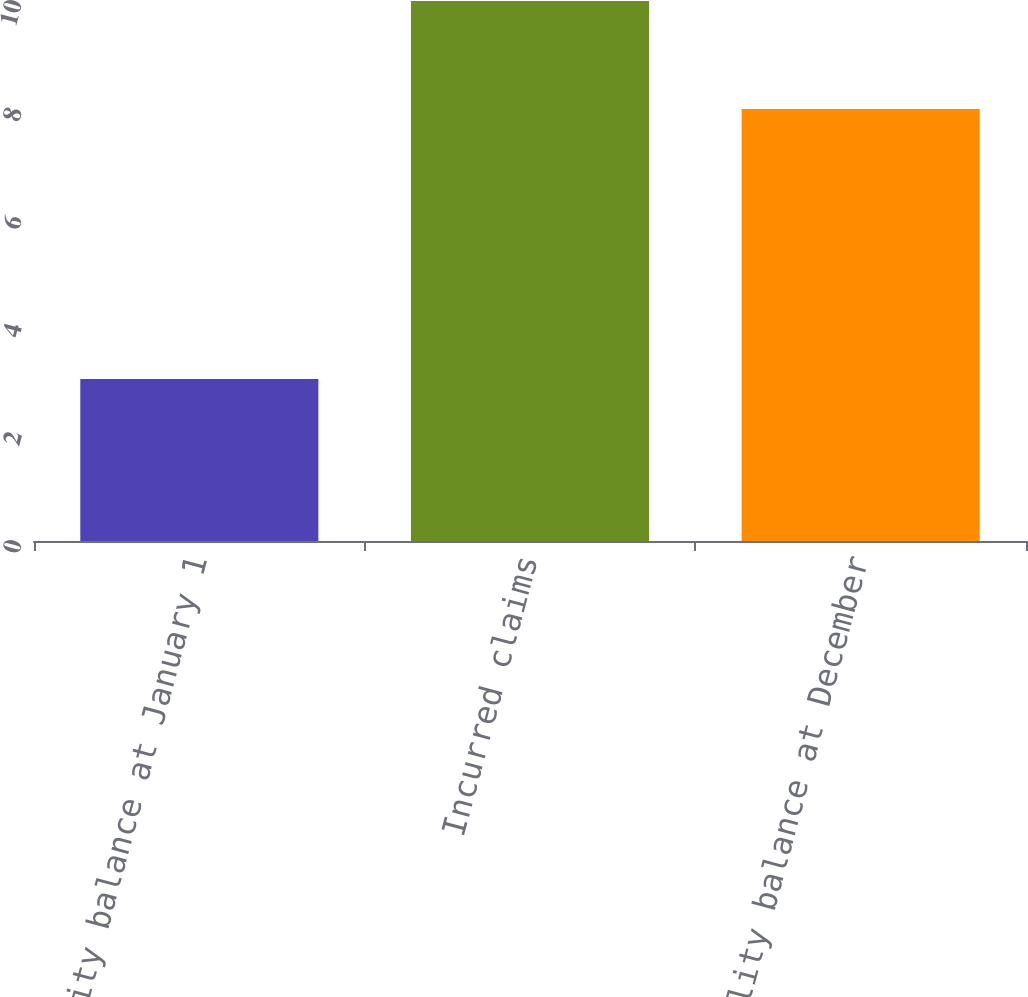Convert chart to OTSL. <chart><loc_0><loc_0><loc_500><loc_500><bar_chart><fcel>Liability balance at January 1<fcel>Incurred claims<fcel>Liability balance at December<nl><fcel>3<fcel>10<fcel>8<nl></chart> 